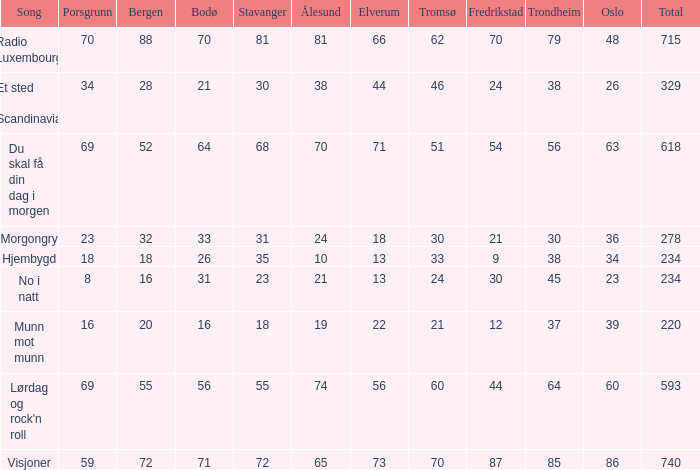When bergen is 88, what is the alesund? 81.0. 